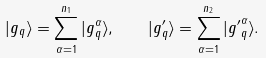Convert formula to latex. <formula><loc_0><loc_0><loc_500><loc_500>| g _ { q } \rangle = \sum _ { \alpha = 1 } ^ { n _ { 1 } } | g _ { q } ^ { \alpha } \rangle , \quad | g _ { q } ^ { \prime } \rangle = \sum _ { \alpha = 1 } ^ { n _ { 2 } } | { g ^ { \prime } } _ { q } ^ { \alpha } \rangle .</formula> 